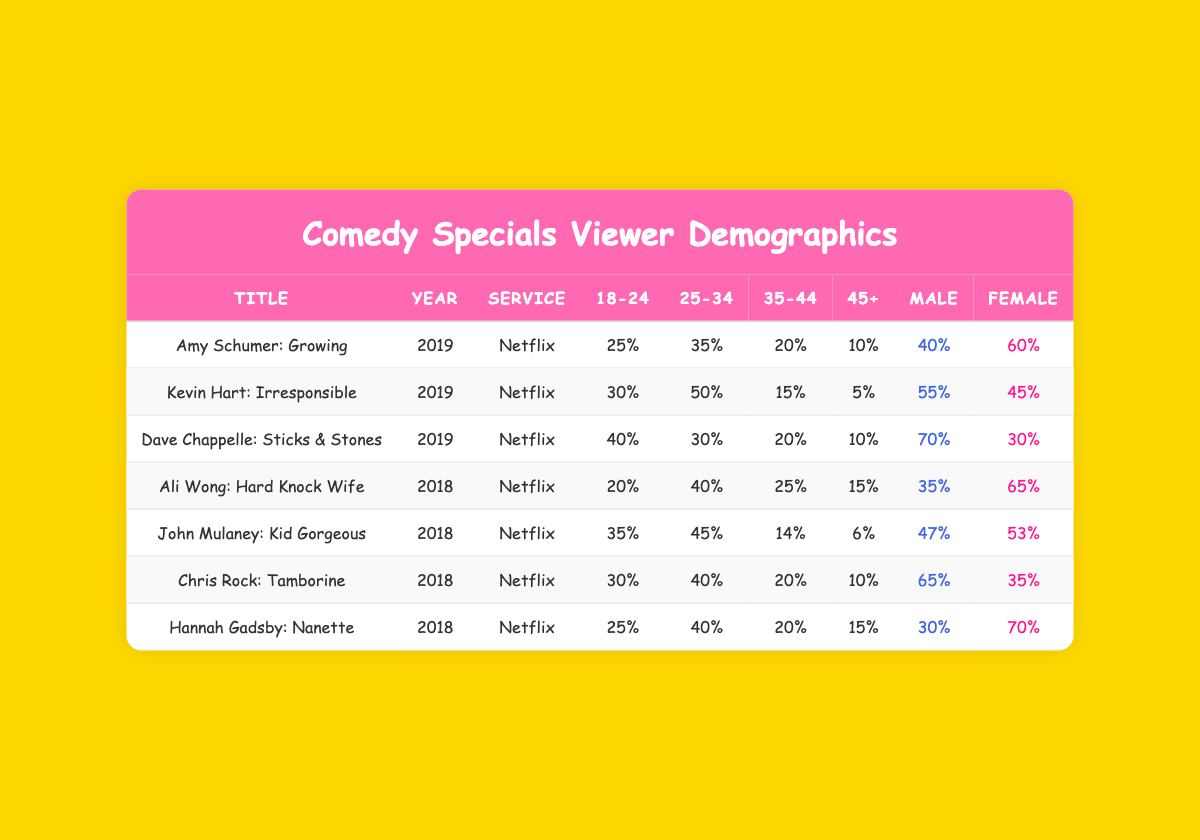What percentage of viewers for "Dave Chappelle: Sticks & Stones" are 35-44? The table shows that for "Dave Chappelle: Sticks & Stones," the percentage of viewers aged 35-44 is 20%.
Answer: 20% Which comedy special has the highest percentage of female viewers? By examining the table, "Hannah Gadsby: Nanette" has the highest percentage of female viewers at 70%.
Answer: 70% What is the total percentage of viewers aged 18-24 across all specials? To find the total percentage of viewers aged 18-24, we add the values: 25 + 30 + 40 + 20 + 35 + 30 + 25 = 235%. Thus, the total percentage is 235%.
Answer: 235% Is the percentage of males higher than females in "Chris Rock: Tamborine"? For "Chris Rock: Tamborine," the male percentage is 65%, while the female percentage is 35%. Since 65% is greater than 35%, the answer is yes.
Answer: Yes What is the average percentage of viewers aged 45+ for all specials? We sum the percentages of viewers aged 45+ from all specials: 10 + 5 + 10 + 15 + 6 + 10 + 15 = 71%. There are 7 specials, so the average is 71/7 = 10.14%.
Answer: 10.14% 